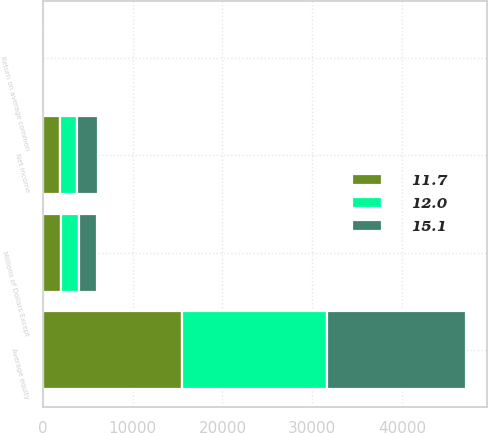Convert chart. <chart><loc_0><loc_0><loc_500><loc_500><stacked_bar_chart><ecel><fcel>Millions of Dollars Except<fcel>Net income<fcel>Average equity<fcel>Return on average common<nl><fcel>12<fcel>2009<fcel>1898<fcel>16194<fcel>11.7<nl><fcel>15.1<fcel>2008<fcel>2338<fcel>15516<fcel>15.1<nl><fcel>11.7<fcel>2007<fcel>1855<fcel>15448<fcel>12<nl></chart> 